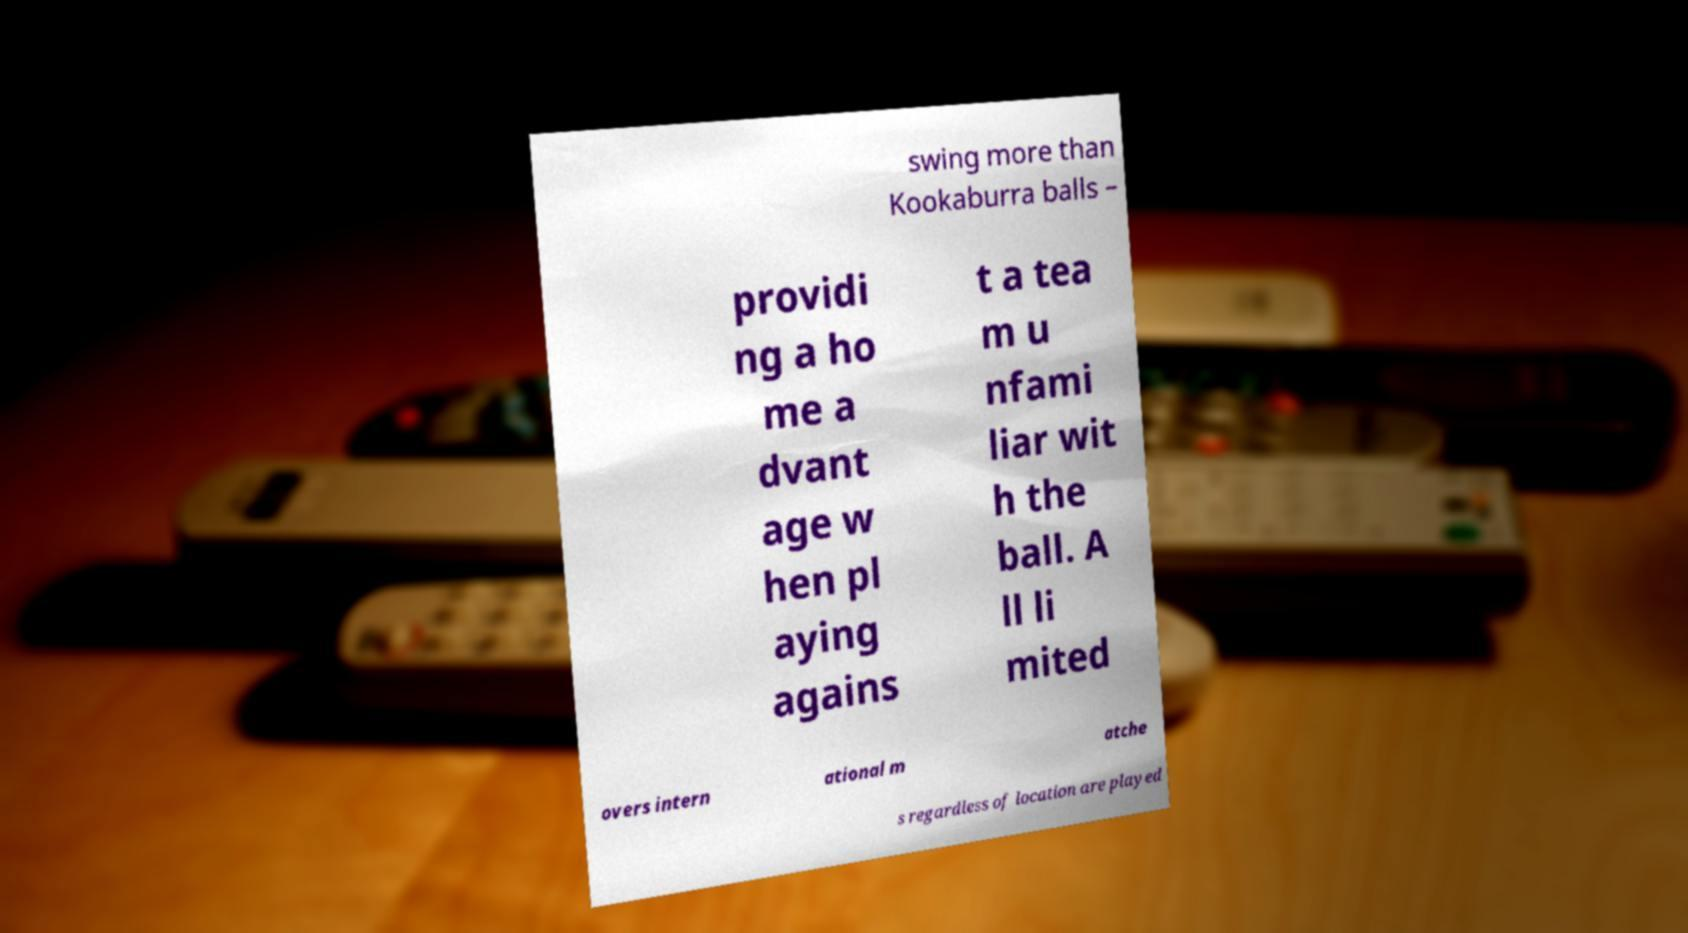What messages or text are displayed in this image? I need them in a readable, typed format. swing more than Kookaburra balls – providi ng a ho me a dvant age w hen pl aying agains t a tea m u nfami liar wit h the ball. A ll li mited overs intern ational m atche s regardless of location are played 